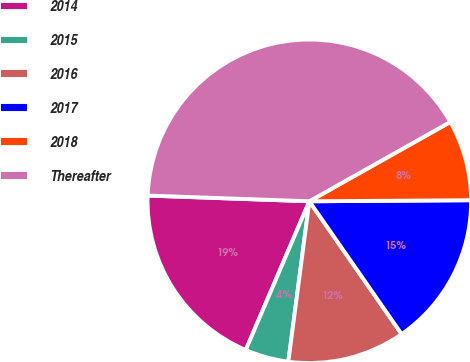Convert chart. <chart><loc_0><loc_0><loc_500><loc_500><pie_chart><fcel>2014<fcel>2015<fcel>2016<fcel>2017<fcel>2018<fcel>Thereafter<nl><fcel>19.13%<fcel>4.36%<fcel>11.74%<fcel>15.44%<fcel>8.05%<fcel>41.28%<nl></chart> 